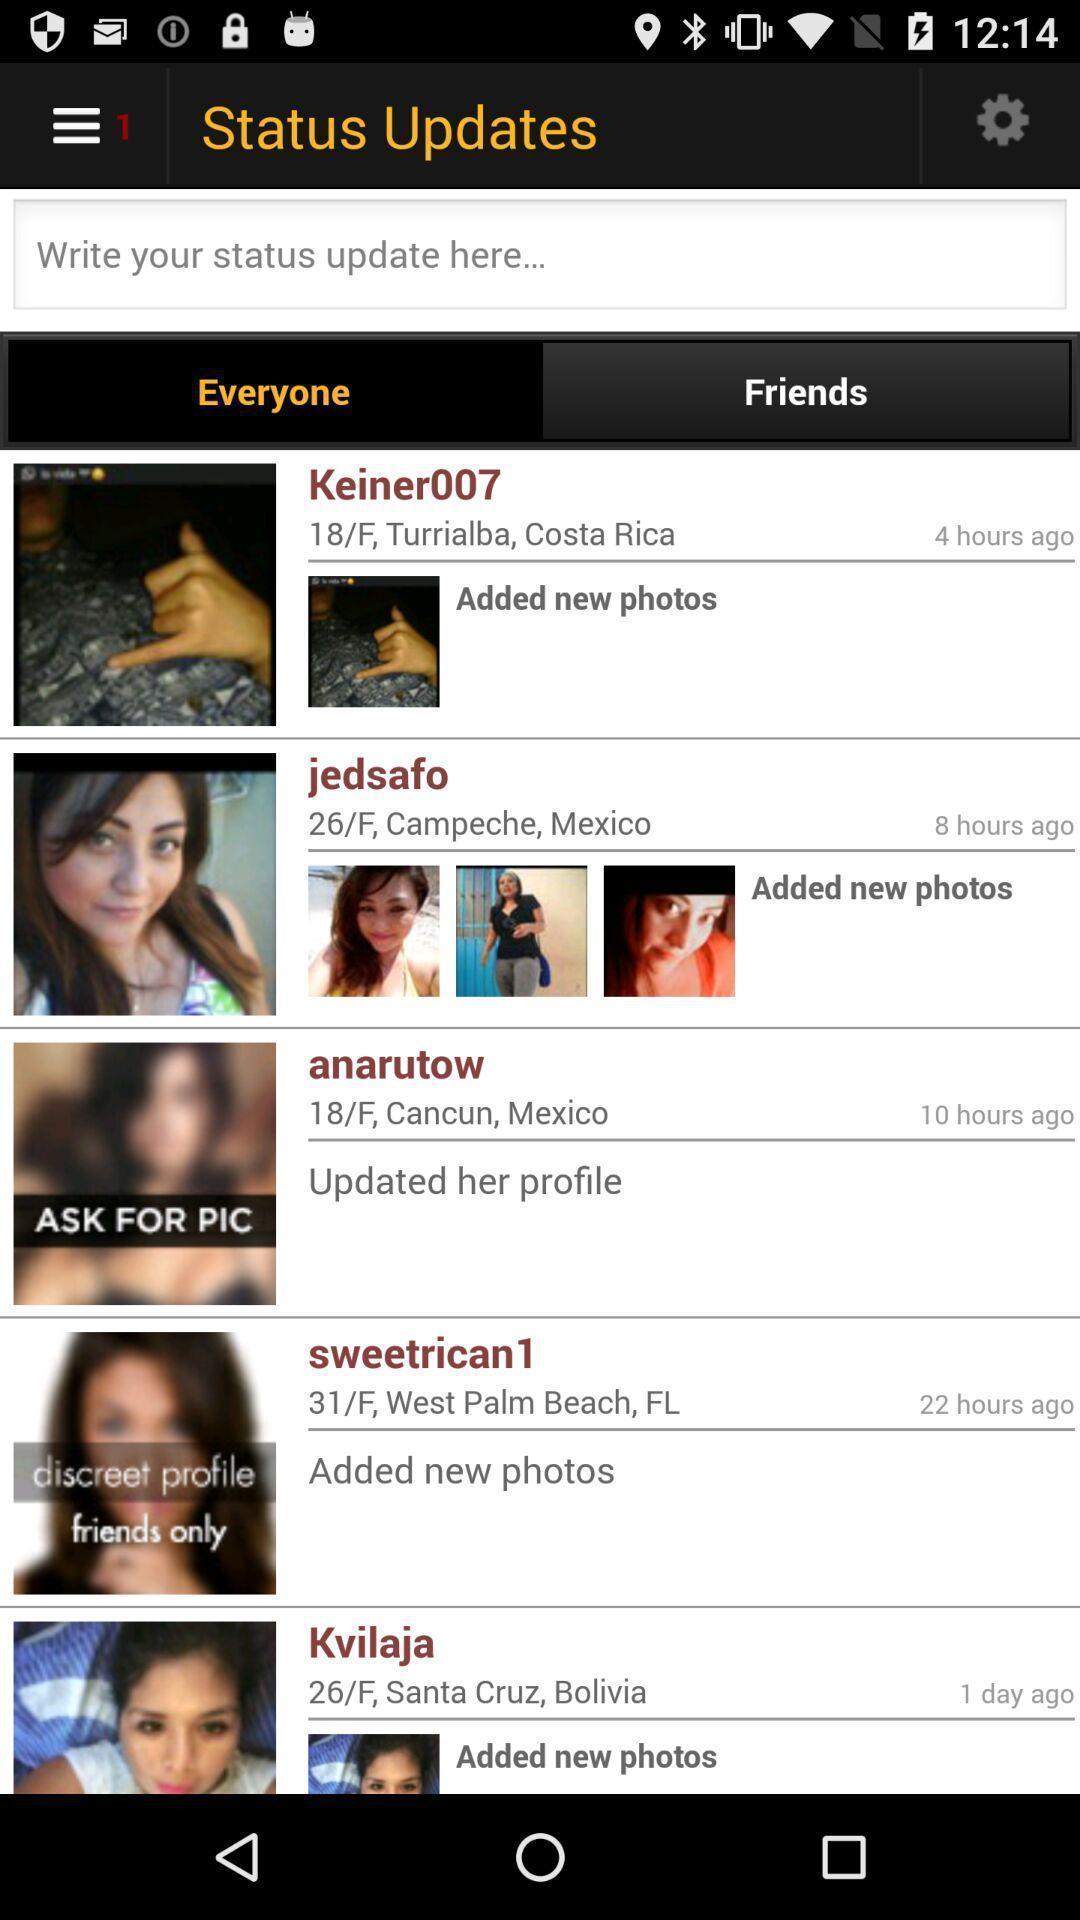Explain the elements present in this screenshot. Social app showing list of status. 